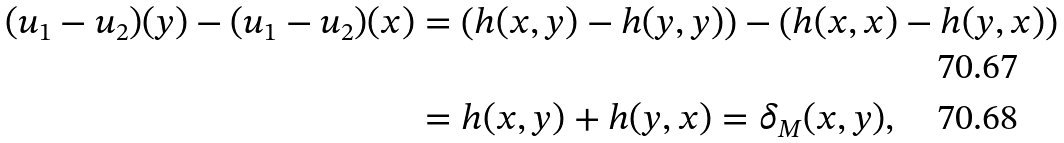<formula> <loc_0><loc_0><loc_500><loc_500>( u _ { 1 } - u _ { 2 } ) ( y ) - ( u _ { 1 } - u _ { 2 } ) ( x ) & = \left ( h ( x , y ) - h ( y , y ) \right ) - \left ( h ( x , x ) - h ( y , x ) \right ) \\ & = h ( x , y ) + h ( y , x ) = \delta _ { M } ( x , y ) ,</formula> 